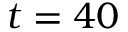Convert formula to latex. <formula><loc_0><loc_0><loc_500><loc_500>t = 4 0</formula> 